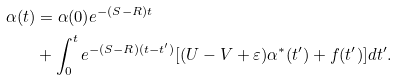Convert formula to latex. <formula><loc_0><loc_0><loc_500><loc_500>\alpha ( t ) & = \alpha ( 0 ) e ^ { - ( S - R ) t } \\ & + \int _ { 0 } ^ { t } e ^ { - ( S - R ) ( t - t ^ { \prime } ) } [ ( U - V + \varepsilon ) \alpha ^ { * } ( t ^ { \prime } ) + f ( t ^ { \prime } ) ] d t ^ { \prime } .</formula> 